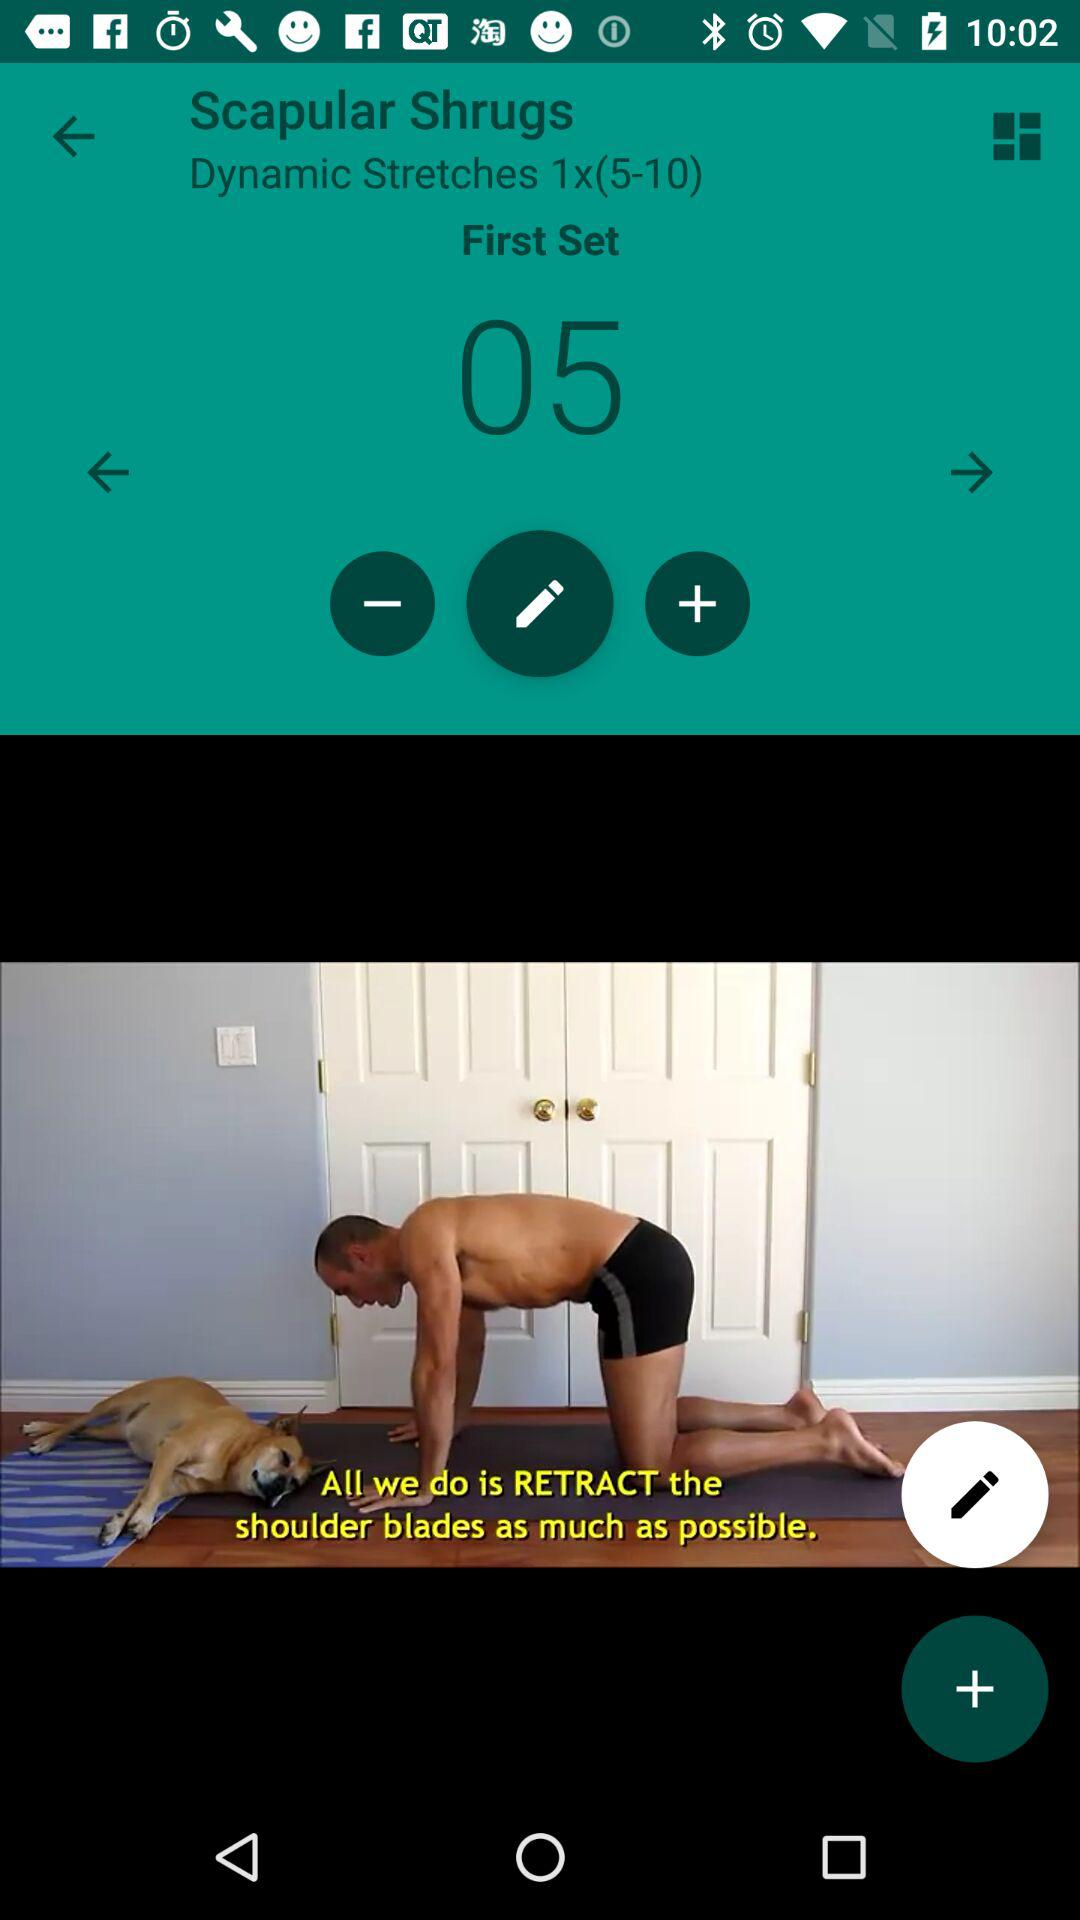How much in the first set? There are 05 in the first set. 